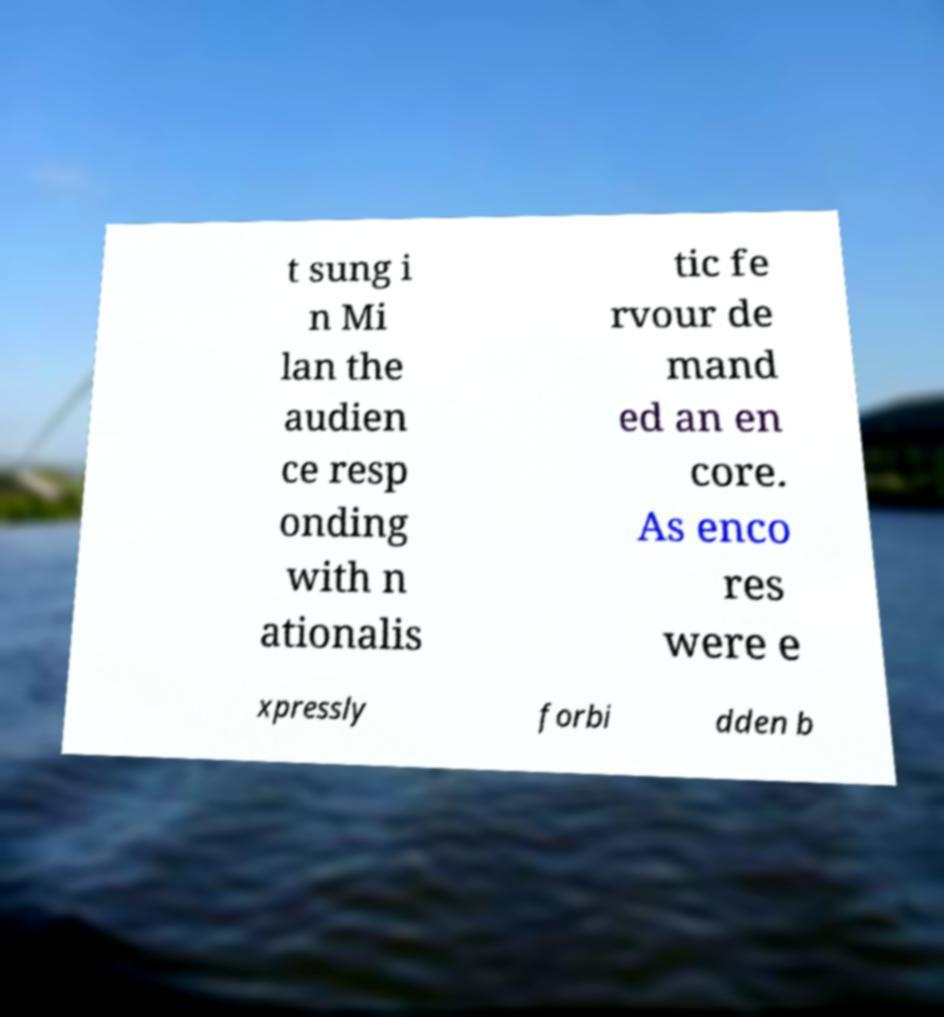What messages or text are displayed in this image? I need them in a readable, typed format. t sung i n Mi lan the audien ce resp onding with n ationalis tic fe rvour de mand ed an en core. As enco res were e xpressly forbi dden b 